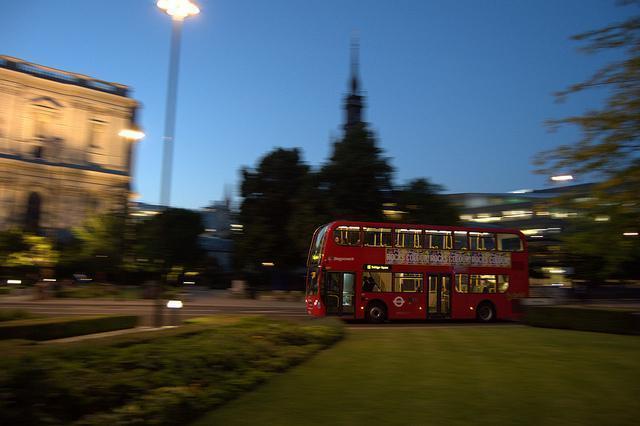How many umbrellas are there?
Give a very brief answer. 0. 